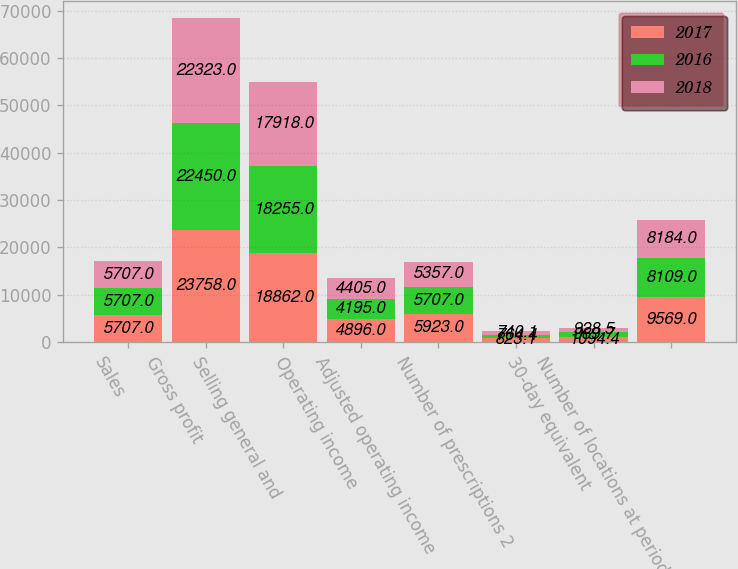Convert chart. <chart><loc_0><loc_0><loc_500><loc_500><stacked_bar_chart><ecel><fcel>Sales<fcel>Gross profit<fcel>Selling general and<fcel>Operating income<fcel>Adjusted operating income<fcel>Number of prescriptions 2<fcel>30-day equivalent<fcel>Number of locations at period<nl><fcel>2017<fcel>5707<fcel>23758<fcel>18862<fcel>4896<fcel>5923<fcel>823.1<fcel>1094.4<fcel>9569<nl><fcel>2016<fcel>5707<fcel>22450<fcel>18255<fcel>4195<fcel>5707<fcel>764.4<fcel>989.7<fcel>8109<nl><fcel>2018<fcel>5707<fcel>22323<fcel>17918<fcel>4405<fcel>5357<fcel>740.1<fcel>928.5<fcel>8184<nl></chart> 